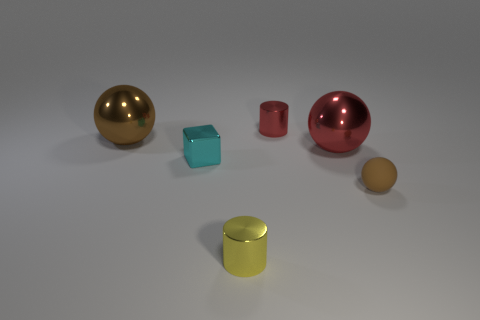Add 2 tiny brown objects. How many objects exist? 8 Subtract all cylinders. How many objects are left? 4 Add 1 cyan metal blocks. How many cyan metal blocks are left? 2 Add 5 large red shiny balls. How many large red shiny balls exist? 6 Subtract 0 red blocks. How many objects are left? 6 Subtract all brown metal things. Subtract all tiny things. How many objects are left? 1 